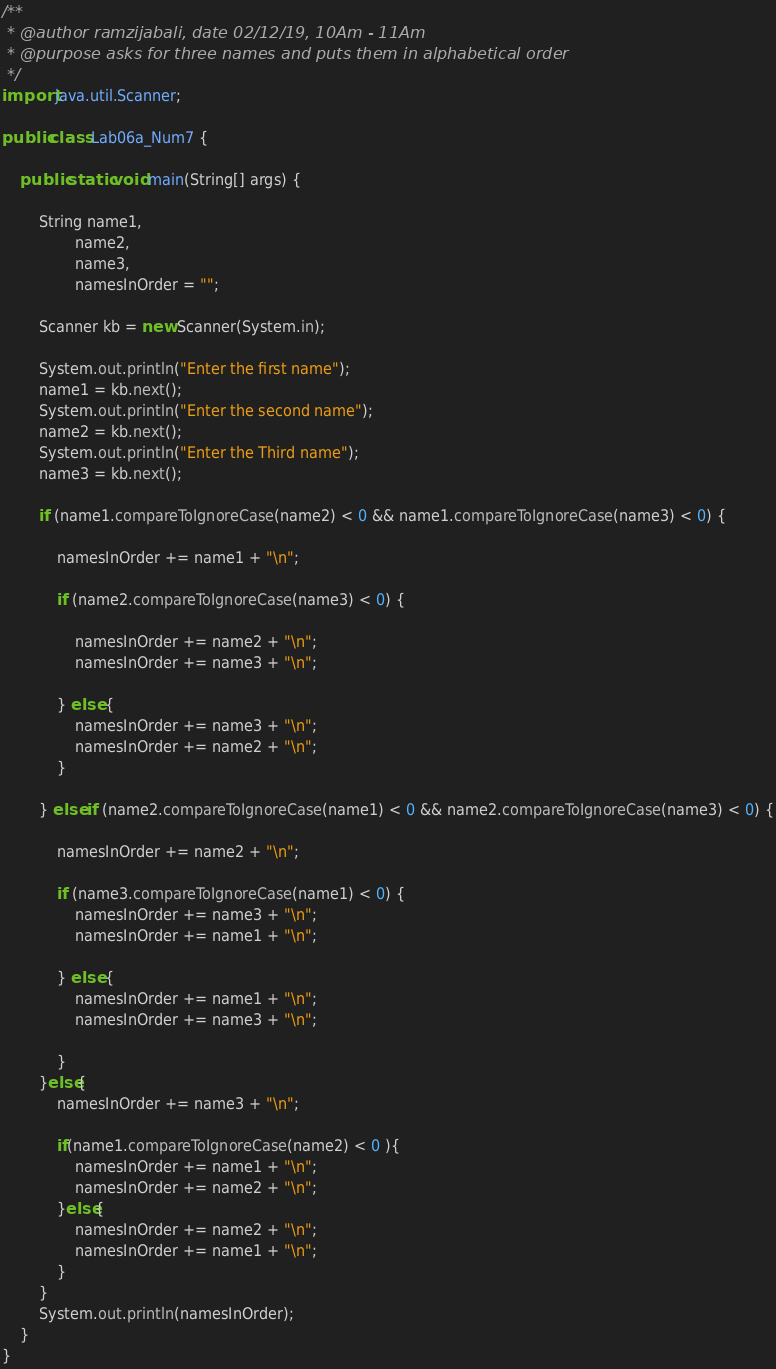Convert code to text. <code><loc_0><loc_0><loc_500><loc_500><_Java_>
/**
 * @author ramzijabali, date 02/12/19, 10Am - 11Am
 * @purpose asks for three names and puts them in alphabetical order
 */
import java.util.Scanner;

public class Lab06a_Num7 {

    public static void main(String[] args) {

        String name1,
                name2,
                name3,
                namesInOrder = "";

        Scanner kb = new Scanner(System.in);

        System.out.println("Enter the first name");
        name1 = kb.next();
        System.out.println("Enter the second name");
        name2 = kb.next();
        System.out.println("Enter the Third name");
        name3 = kb.next();

        if (name1.compareToIgnoreCase(name2) < 0 && name1.compareToIgnoreCase(name3) < 0) {

            namesInOrder += name1 + "\n";

            if (name2.compareToIgnoreCase(name3) < 0) {

                namesInOrder += name2 + "\n";
                namesInOrder += name3 + "\n";

            } else {
                namesInOrder += name3 + "\n";
                namesInOrder += name2 + "\n";
            }

        } else if (name2.compareToIgnoreCase(name1) < 0 && name2.compareToIgnoreCase(name3) < 0) {

            namesInOrder += name2 + "\n";

            if (name3.compareToIgnoreCase(name1) < 0) {
                namesInOrder += name3 + "\n";
                namesInOrder += name1 + "\n";

            } else {
                namesInOrder += name1 + "\n";
                namesInOrder += name3 + "\n";

            }
        }else{
            namesInOrder += name3 + "\n";
            
            if(name1.compareToIgnoreCase(name2) < 0 ){
                namesInOrder += name1 + "\n";
                namesInOrder += name2 + "\n";
            }else{
                namesInOrder += name2 + "\n";
                namesInOrder += name1 + "\n";
            }
        }
        System.out.println(namesInOrder);
    }
}
</code> 